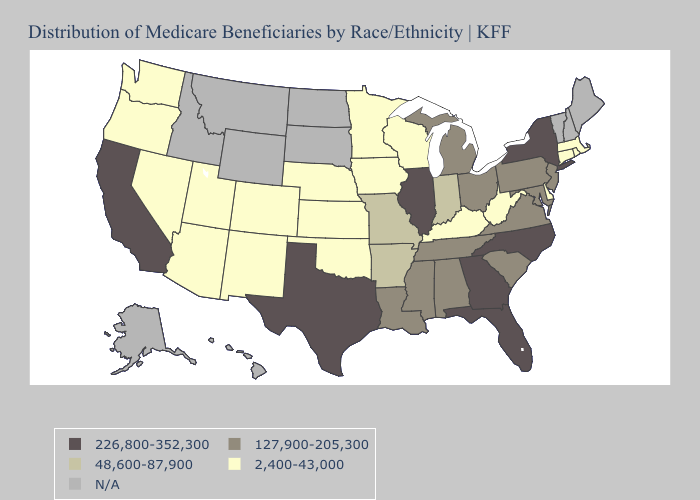What is the highest value in states that border California?
Short answer required. 2,400-43,000. Does Rhode Island have the highest value in the USA?
Short answer required. No. Does the first symbol in the legend represent the smallest category?
Give a very brief answer. No. Name the states that have a value in the range 48,600-87,900?
Keep it brief. Arkansas, Indiana, Missouri. Name the states that have a value in the range 226,800-352,300?
Be succinct. California, Florida, Georgia, Illinois, New York, North Carolina, Texas. What is the lowest value in the West?
Keep it brief. 2,400-43,000. What is the value of Indiana?
Be succinct. 48,600-87,900. What is the value of Oregon?
Answer briefly. 2,400-43,000. Does Nebraska have the highest value in the USA?
Keep it brief. No. What is the highest value in the South ?
Be succinct. 226,800-352,300. Does North Carolina have the highest value in the South?
Answer briefly. Yes. Does Connecticut have the lowest value in the Northeast?
Give a very brief answer. Yes. What is the value of Oregon?
Concise answer only. 2,400-43,000. Name the states that have a value in the range 2,400-43,000?
Concise answer only. Arizona, Colorado, Connecticut, Delaware, Iowa, Kansas, Kentucky, Massachusetts, Minnesota, Nebraska, Nevada, New Mexico, Oklahoma, Oregon, Rhode Island, Utah, Washington, West Virginia, Wisconsin. 